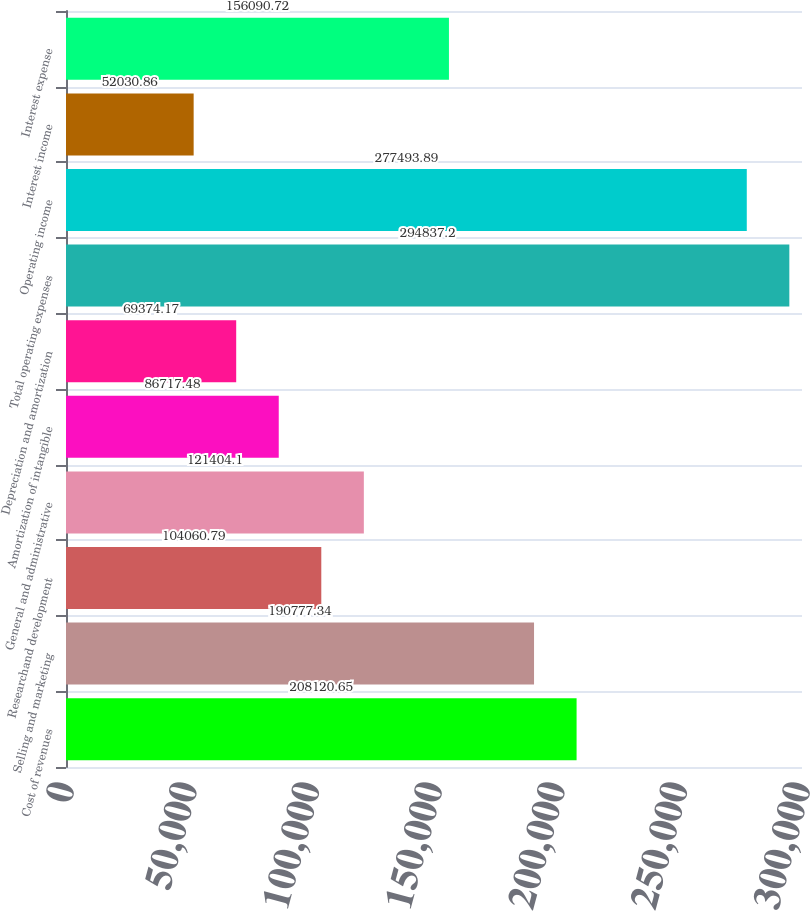Convert chart to OTSL. <chart><loc_0><loc_0><loc_500><loc_500><bar_chart><fcel>Cost of revenues<fcel>Selling and marketing<fcel>Researchand development<fcel>General and administrative<fcel>Amortization of intangible<fcel>Depreciation and amortization<fcel>Total operating expenses<fcel>Operating income<fcel>Interest income<fcel>Interest expense<nl><fcel>208121<fcel>190777<fcel>104061<fcel>121404<fcel>86717.5<fcel>69374.2<fcel>294837<fcel>277494<fcel>52030.9<fcel>156091<nl></chart> 